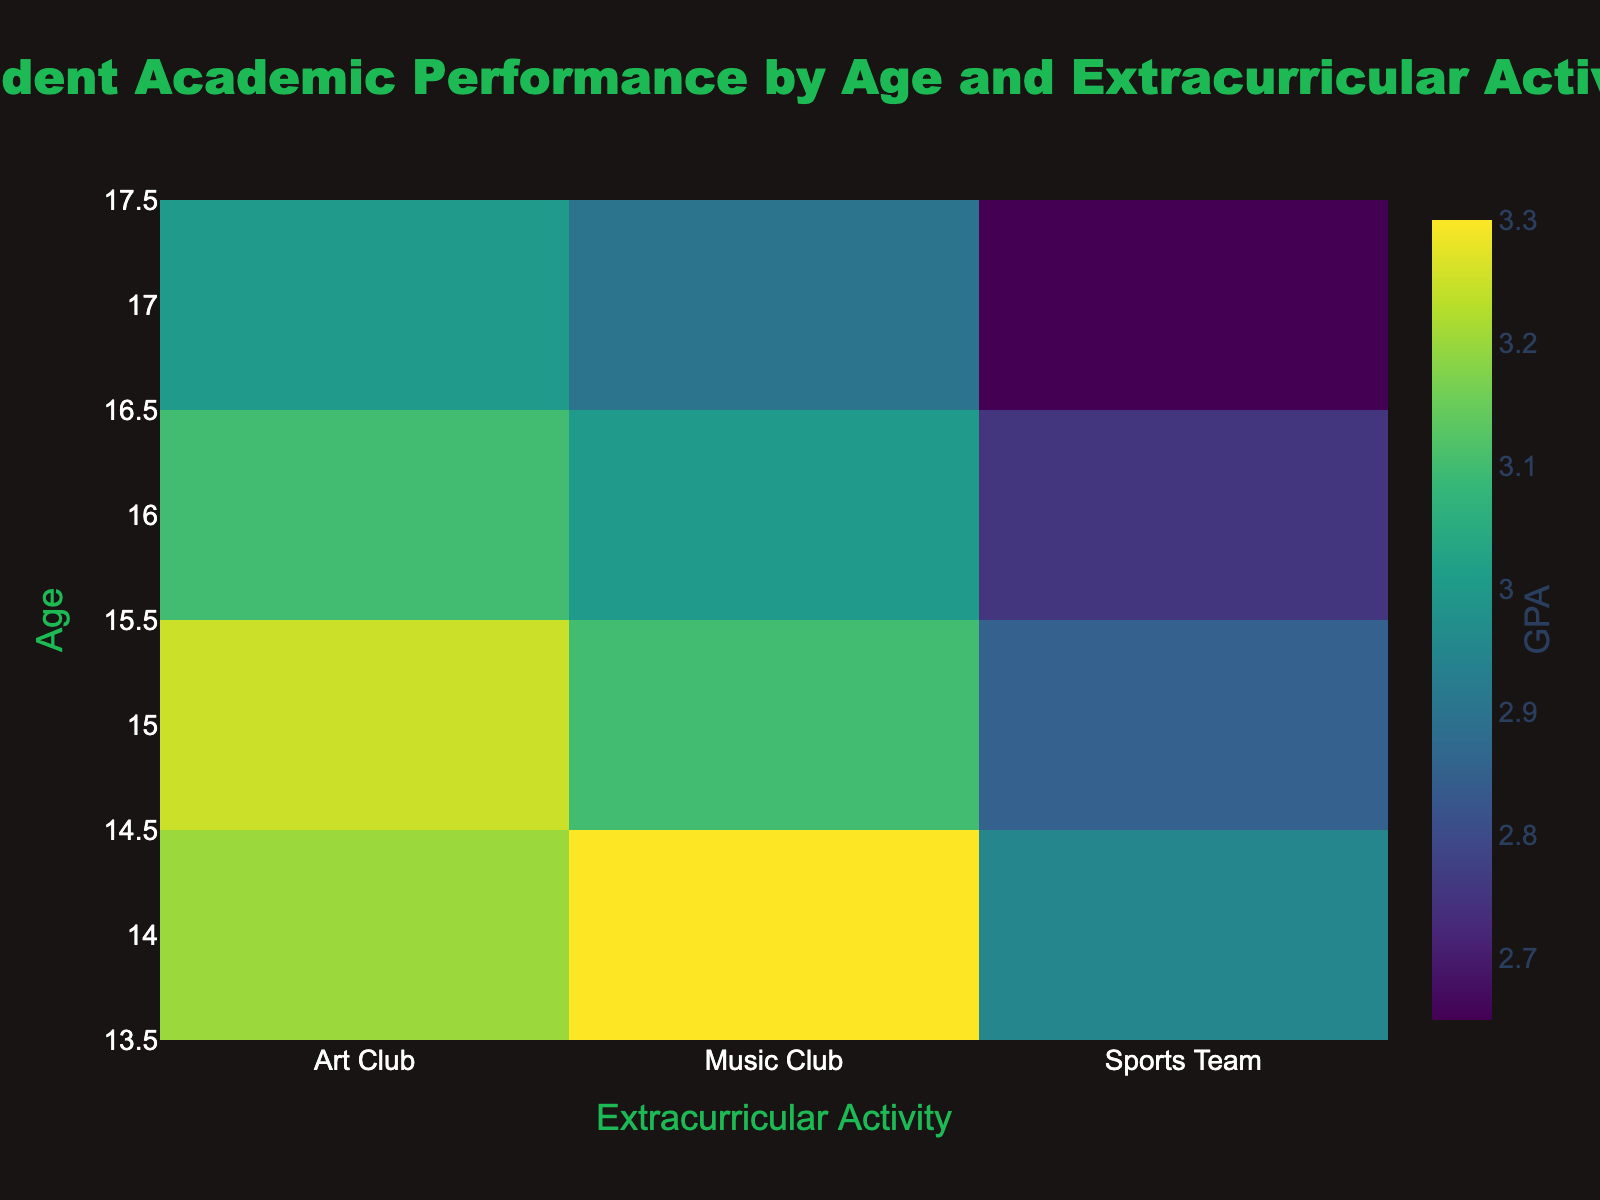What's the title of the figure? The title is usually displayed at the top center of the figure. In this case, it reads "Student Academic Performance by Age and Extracurricular Activity."
Answer: Student Academic Performance by Age and Extracurricular Activity Which extracurricular activity has the highest average GPA for 14-year-olds? To find this, look at the row corresponding to age 14. Among Music Club, Sports Team, and Art Club, check which has the highest value. From the figure, it is Art Club.
Answer: Art Club What is the average GPA for 16-year-olds participating in the Sports Team? Find the intersection of the 16-year-olds row and the Sports Team column. Read the GPA value directly from the heatmap.
Answer: 2.75 Which age group has the lowest average GPA in the Sports Team? Compare the GPA values for the Sports Team column across all age groups. The age group with the lowest value is 17-year-olds.
Answer: 17-year-olds How does the average GPA for 15-year-olds in the Music Club compare to 16-year-olds in the Music Club? Look at the Music Club column and compare the GPA for ages 15 and 16. The GPA for 15-year-olds is higher (3.1 vs. 3.0).
Answer: 15-year-olds have higher GPA What is the overall trend in GPA for students participating in the Art Club as they age? Observe the GPAs in the Art Club column from age 14 to 17. The values show a decreasing trend as students get older.
Answer: Decreasing trend Which extracurricular activity shows the greatest variance in GPA across different ages? Compare the range (difference between highest and lowest values) of GPA across different ages for each extracurricular activity. The Sports Team shows the greatest variance (ranging from 2.6 to 3.0).
Answer: Sports Team What can you infer about the correlation between age and academic performance in the Music Club? Look at the GPA values for the Music Club across ages 14 to 17. There is a declining trend, indicating a negative correlation between age and GPA in the Music Club.
Answer: Negative correlation At what age do students in the Art Club have the highest GPA? Check the Art Club column for the highest GPA and note the corresponding age. It is 14 years old.
Answer: 14 years old 